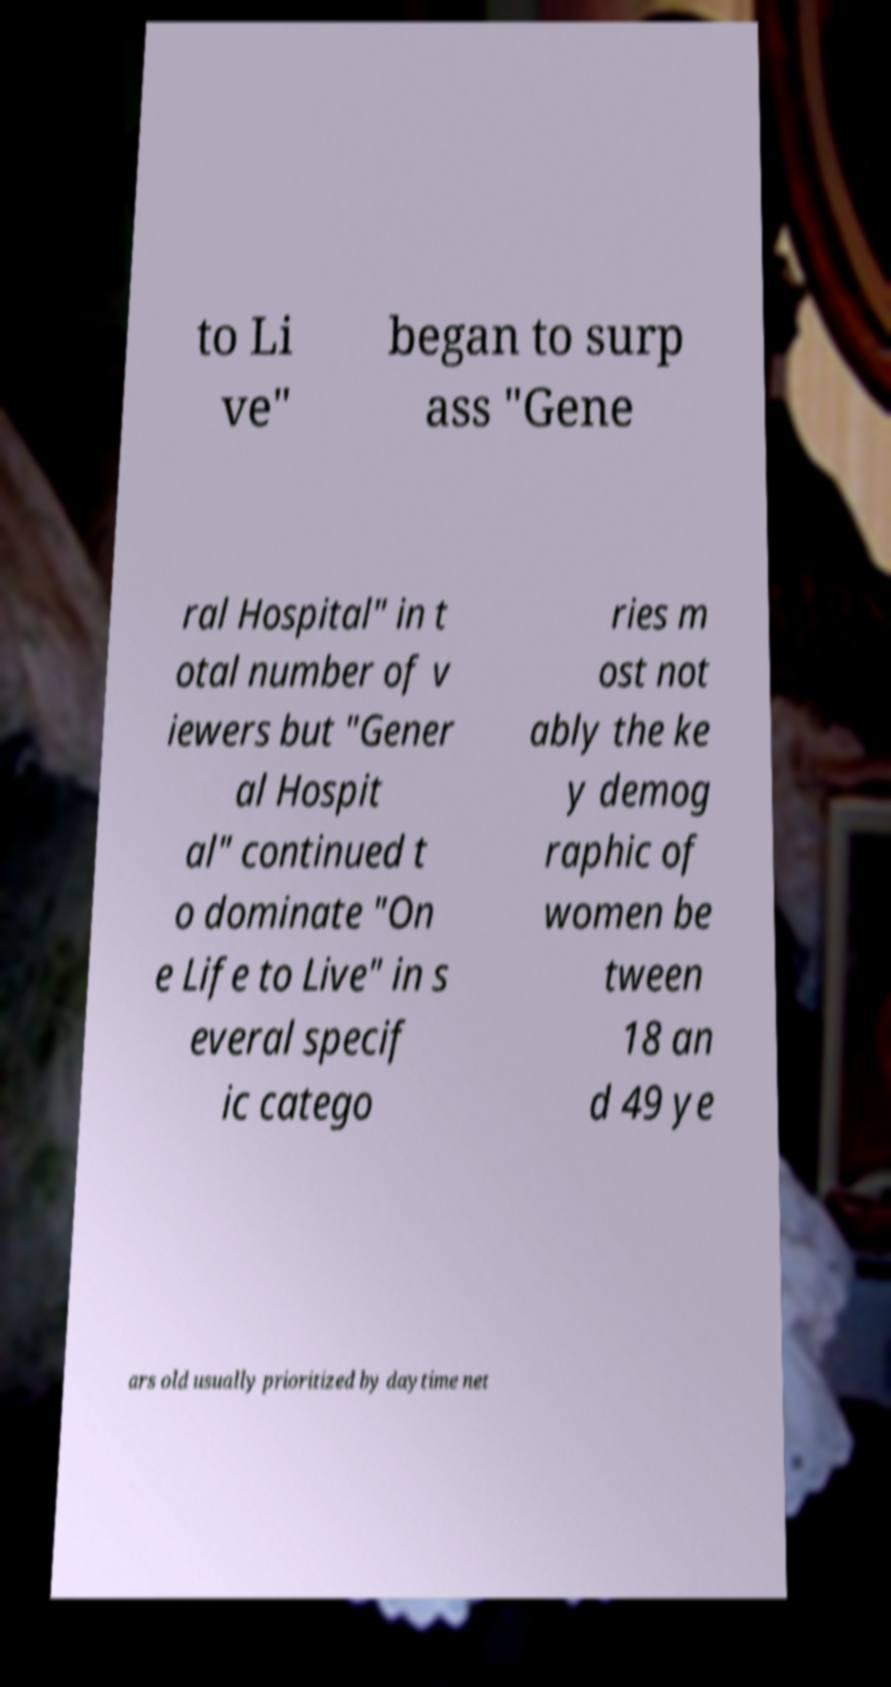Could you assist in decoding the text presented in this image and type it out clearly? to Li ve" began to surp ass "Gene ral Hospital" in t otal number of v iewers but "Gener al Hospit al" continued t o dominate "On e Life to Live" in s everal specif ic catego ries m ost not ably the ke y demog raphic of women be tween 18 an d 49 ye ars old usually prioritized by daytime net 